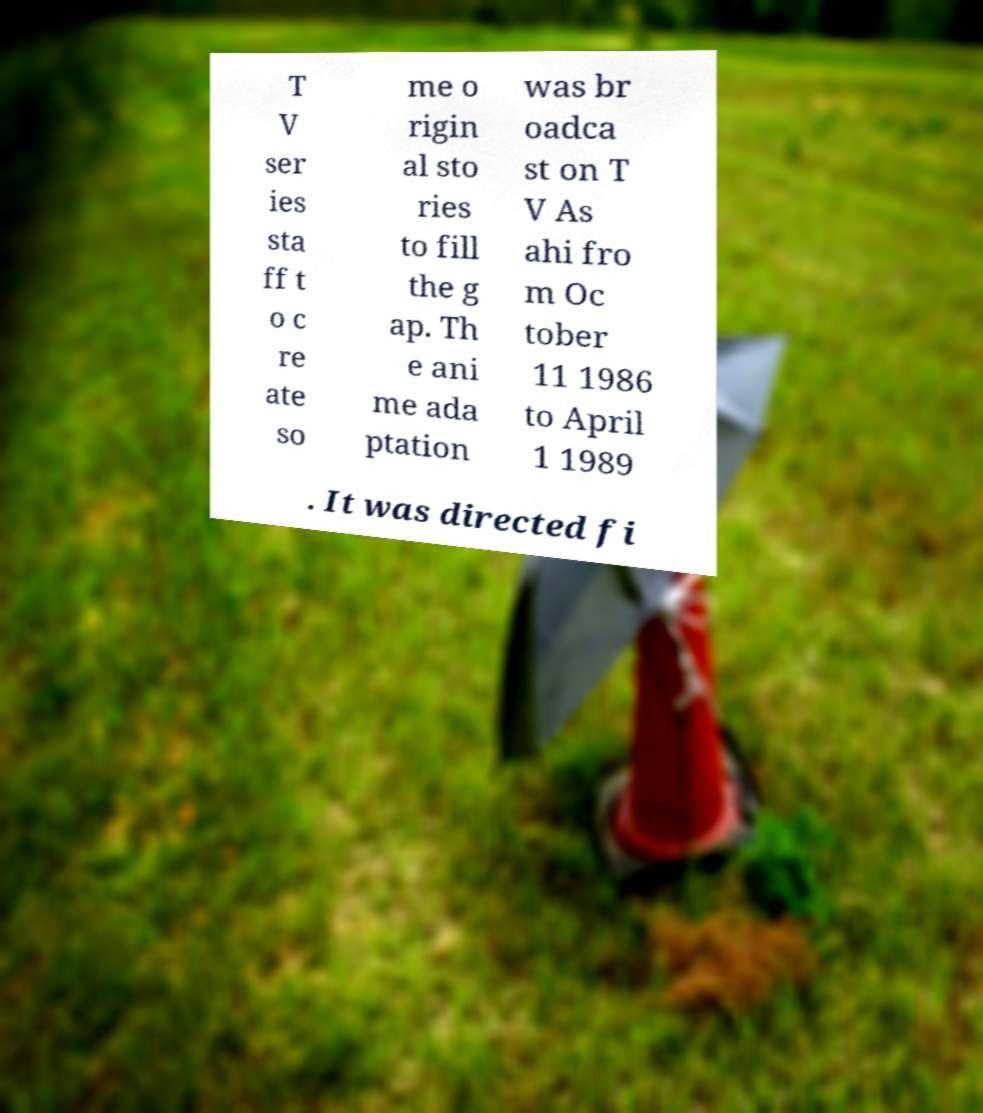What messages or text are displayed in this image? I need them in a readable, typed format. T V ser ies sta ff t o c re ate so me o rigin al sto ries to fill the g ap. Th e ani me ada ptation was br oadca st on T V As ahi fro m Oc tober 11 1986 to April 1 1989 . It was directed fi 